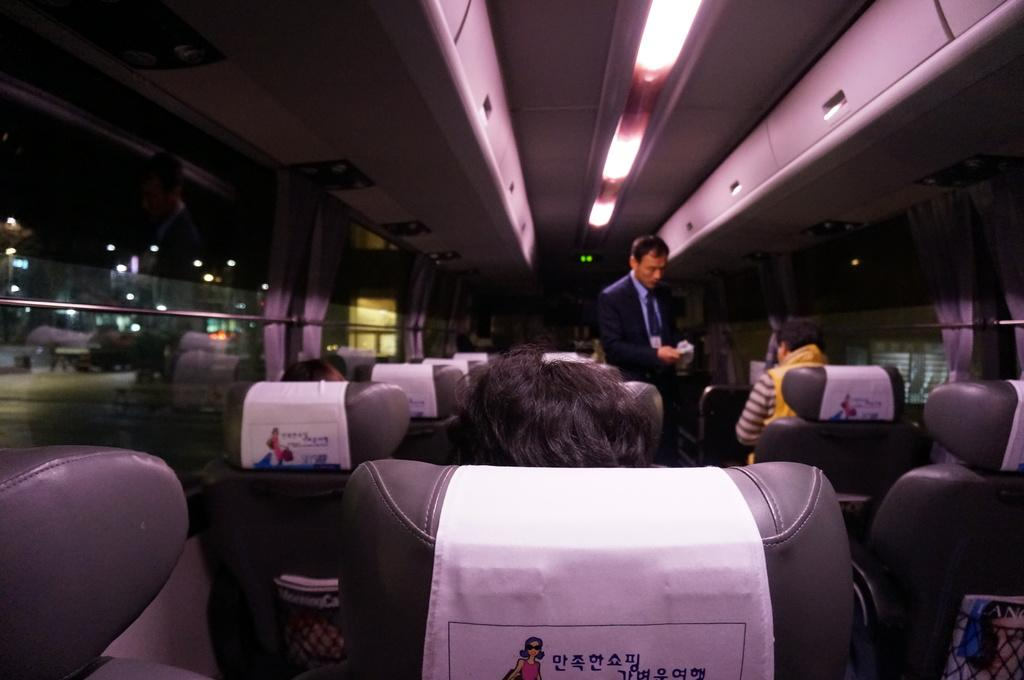Where was the image taken? The image was taken inside a bus. What can be found inside the bus? There are seats in the bus, and people are sitting on them. Is there anyone standing in the bus? Yes, there is a man standing in the bus. What is used to provide light inside the bus? There are lights at the top of the bus. Are there any window treatments in the bus? Yes, curtains are present in the bus. What type of dust can be seen on the seats in the image? There is no dust visible on the seats in the image. Can you see a bat flying around inside the bus in the image? There is no bat present in the image; it is taken inside a bus with people sitting and standing. 